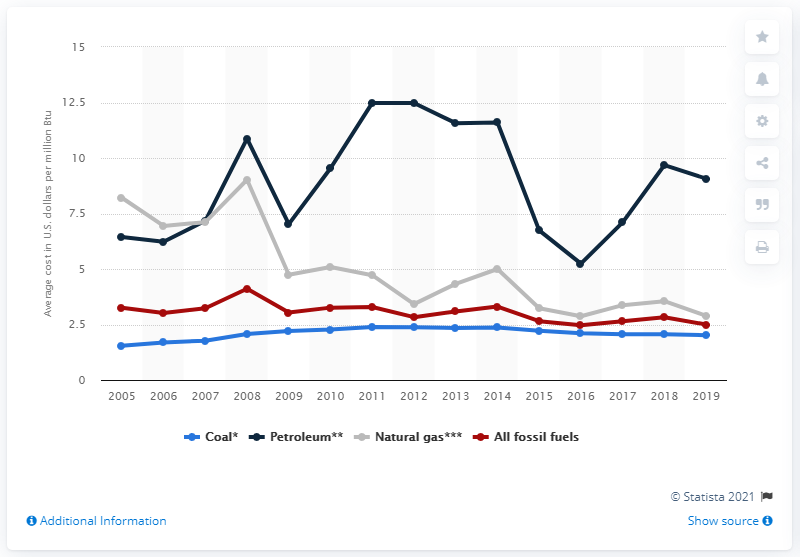Indicate a few pertinent items in this graphic. The average cost of fossil fuels in the electric power industry is 2.5. 